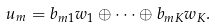<formula> <loc_0><loc_0><loc_500><loc_500>u _ { m } = b _ { m 1 } w _ { 1 } \oplus \dots \oplus b _ { m K } w _ { K } .</formula> 